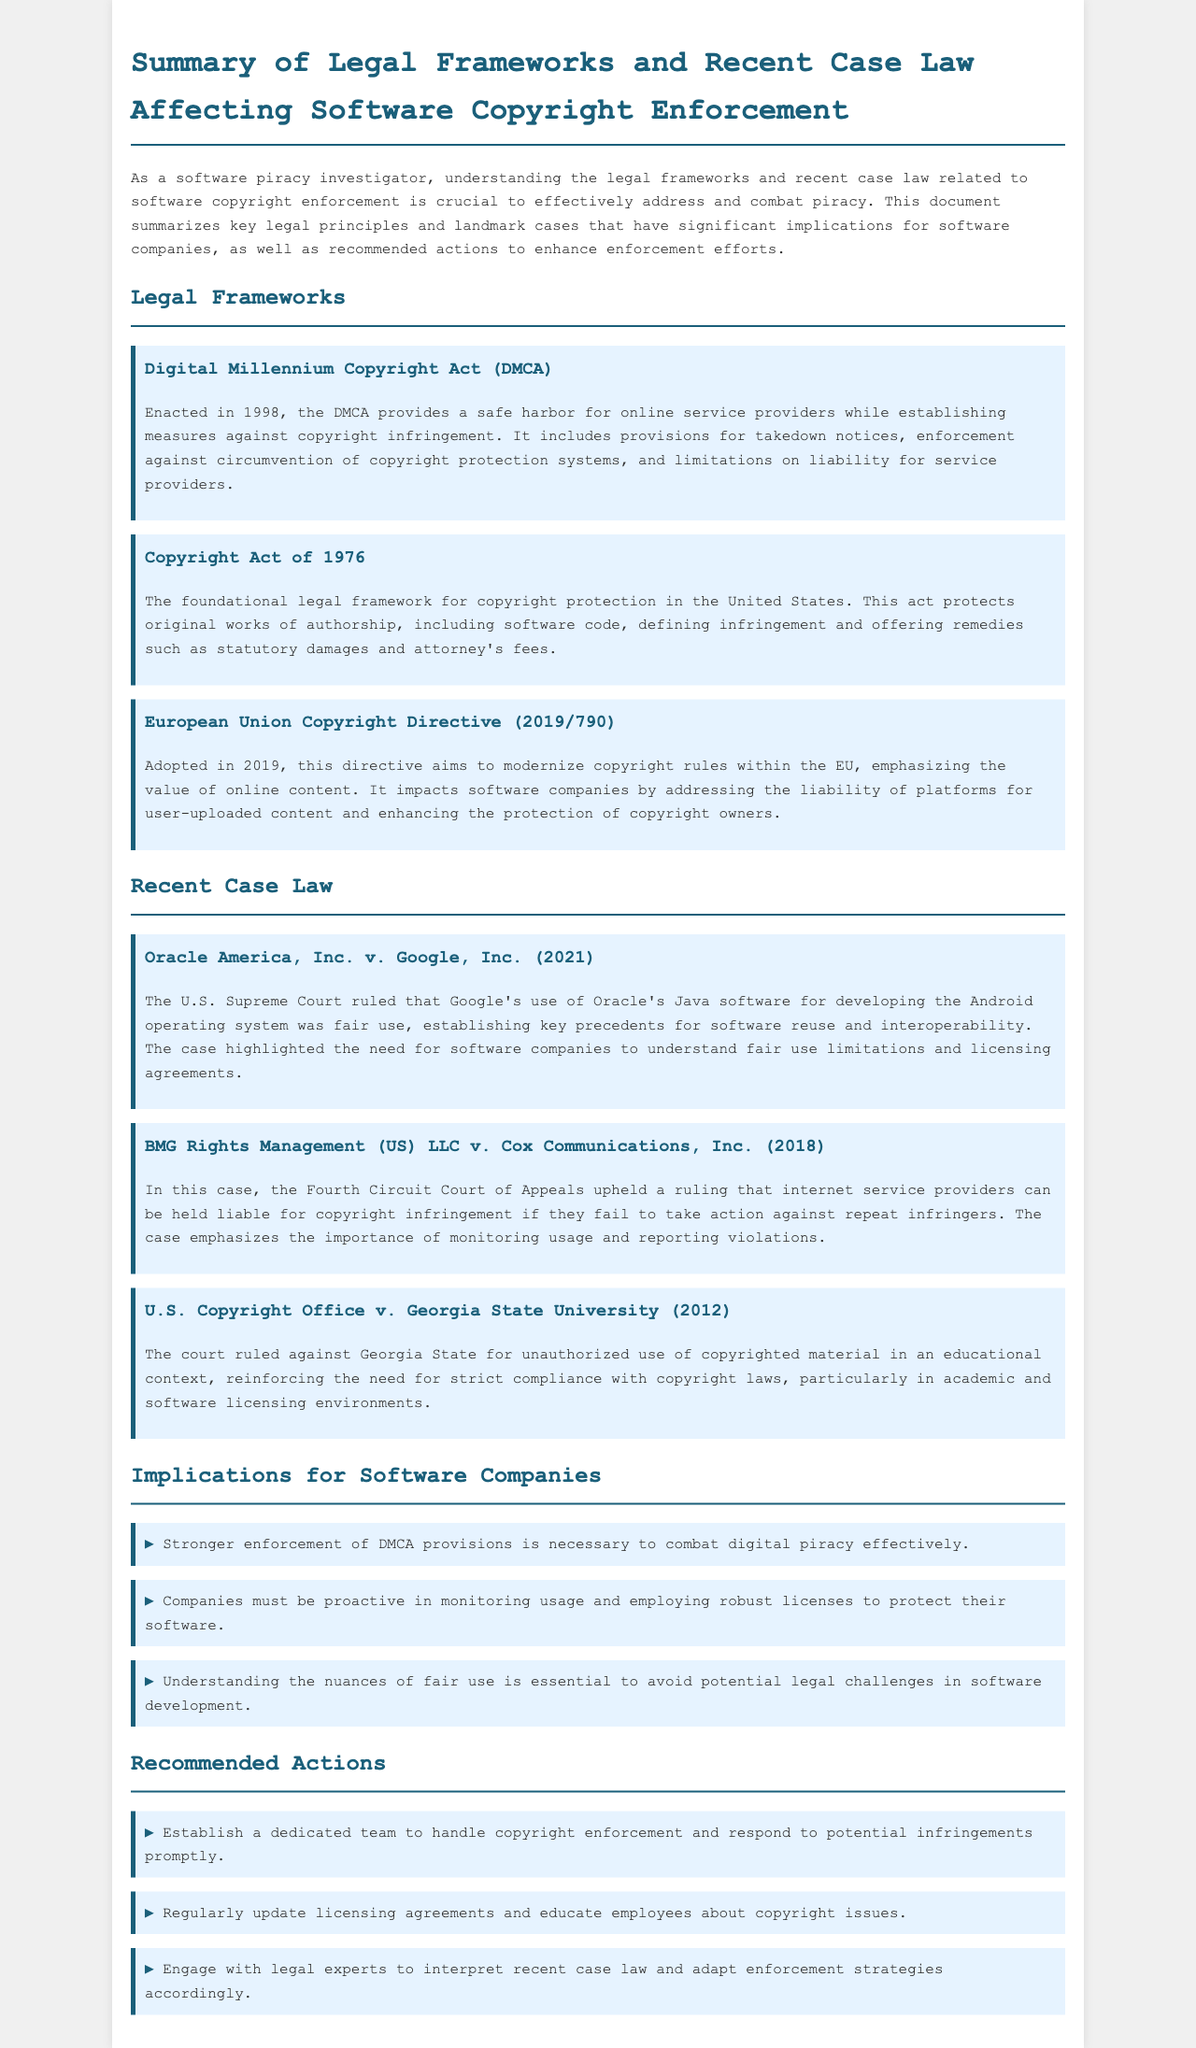What year was the DMCA enacted? The DMCA was enacted in 1998.
Answer: 1998 What is one key aspect of the European Union Copyright Directive? The directive addresses the liability of platforms for user-uploaded content.
Answer: Liability of platforms Which case emphasized the need for monitoring usage by internet service providers? The case BMG Rights Management v. Cox Communications upheld this principle.
Answer: BMG Rights Management v. Cox Communications What is one recommended action for software companies regarding licensing? Companies should regularly update licensing agreements.
Answer: Regularly update licensing agreements What was the ruling in Oracle America, Inc. v. Google, Inc.? The U.S. Supreme Court ruled that Google's use of Oracle's software was fair use.
Answer: Fair use 